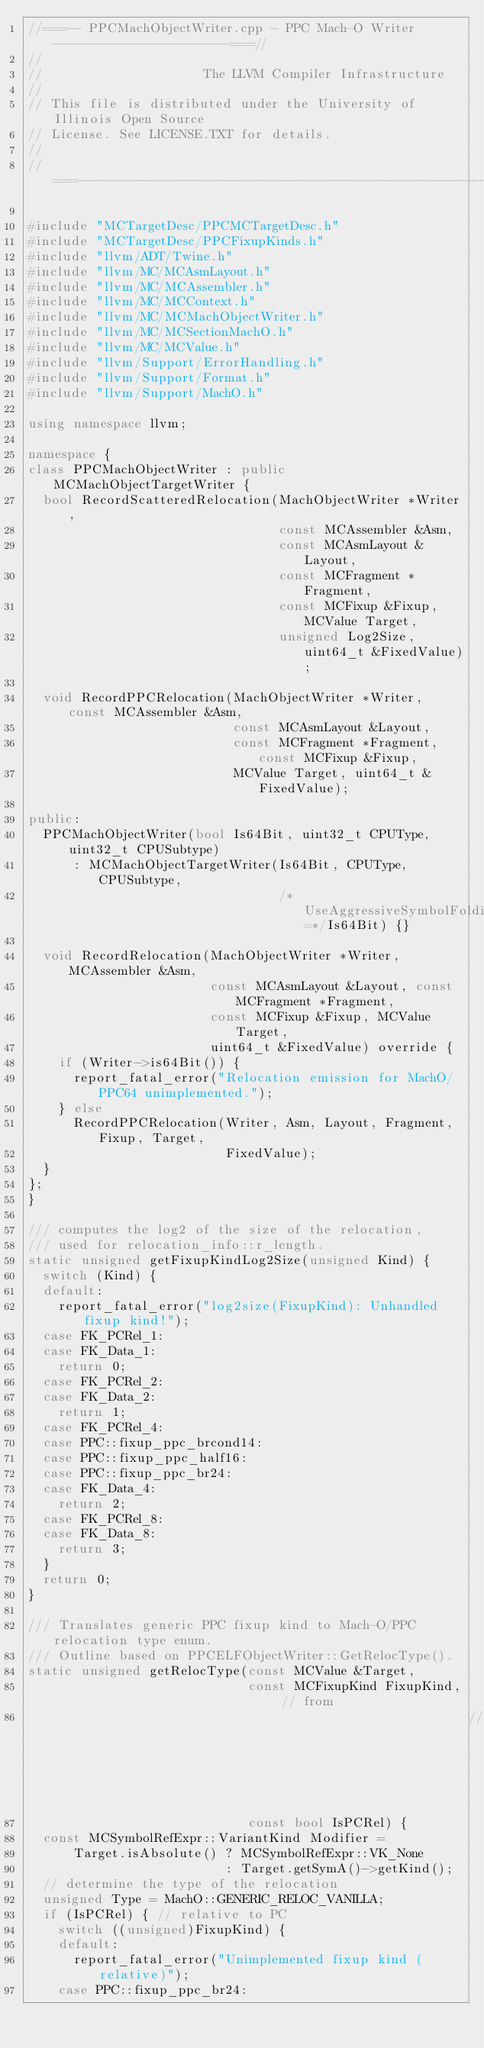Convert code to text. <code><loc_0><loc_0><loc_500><loc_500><_C++_>//===-- PPCMachObjectWriter.cpp - PPC Mach-O Writer -----------------------===//
//
//                     The LLVM Compiler Infrastructure
//
// This file is distributed under the University of Illinois Open Source
// License. See LICENSE.TXT for details.
//
//===----------------------------------------------------------------------===//

#include "MCTargetDesc/PPCMCTargetDesc.h"
#include "MCTargetDesc/PPCFixupKinds.h"
#include "llvm/ADT/Twine.h"
#include "llvm/MC/MCAsmLayout.h"
#include "llvm/MC/MCAssembler.h"
#include "llvm/MC/MCContext.h"
#include "llvm/MC/MCMachObjectWriter.h"
#include "llvm/MC/MCSectionMachO.h"
#include "llvm/MC/MCValue.h"
#include "llvm/Support/ErrorHandling.h"
#include "llvm/Support/Format.h"
#include "llvm/Support/MachO.h"

using namespace llvm;

namespace {
class PPCMachObjectWriter : public MCMachObjectTargetWriter {
  bool RecordScatteredRelocation(MachObjectWriter *Writer,
                                 const MCAssembler &Asm,
                                 const MCAsmLayout &Layout,
                                 const MCFragment *Fragment,
                                 const MCFixup &Fixup, MCValue Target,
                                 unsigned Log2Size, uint64_t &FixedValue);

  void RecordPPCRelocation(MachObjectWriter *Writer, const MCAssembler &Asm,
                           const MCAsmLayout &Layout,
                           const MCFragment *Fragment, const MCFixup &Fixup,
                           MCValue Target, uint64_t &FixedValue);

public:
  PPCMachObjectWriter(bool Is64Bit, uint32_t CPUType, uint32_t CPUSubtype)
      : MCMachObjectTargetWriter(Is64Bit, CPUType, CPUSubtype,
                                 /*UseAggressiveSymbolFolding=*/Is64Bit) {}

  void RecordRelocation(MachObjectWriter *Writer, MCAssembler &Asm,
                        const MCAsmLayout &Layout, const MCFragment *Fragment,
                        const MCFixup &Fixup, MCValue Target,
                        uint64_t &FixedValue) override {
    if (Writer->is64Bit()) {
      report_fatal_error("Relocation emission for MachO/PPC64 unimplemented.");
    } else
      RecordPPCRelocation(Writer, Asm, Layout, Fragment, Fixup, Target,
                          FixedValue);
  }
};
}

/// computes the log2 of the size of the relocation,
/// used for relocation_info::r_length.
static unsigned getFixupKindLog2Size(unsigned Kind) {
  switch (Kind) {
  default:
    report_fatal_error("log2size(FixupKind): Unhandled fixup kind!");
  case FK_PCRel_1:
  case FK_Data_1:
    return 0;
  case FK_PCRel_2:
  case FK_Data_2:
    return 1;
  case FK_PCRel_4:
  case PPC::fixup_ppc_brcond14:
  case PPC::fixup_ppc_half16:
  case PPC::fixup_ppc_br24:
  case FK_Data_4:
    return 2;
  case FK_PCRel_8:
  case FK_Data_8:
    return 3;
  }
  return 0;
}

/// Translates generic PPC fixup kind to Mach-O/PPC relocation type enum.
/// Outline based on PPCELFObjectWriter::GetRelocType().
static unsigned getRelocType(const MCValue &Target,
                             const MCFixupKind FixupKind, // from
                                                          // Fixup.getKind()
                             const bool IsPCRel) {
  const MCSymbolRefExpr::VariantKind Modifier =
      Target.isAbsolute() ? MCSymbolRefExpr::VK_None
                          : Target.getSymA()->getKind();
  // determine the type of the relocation
  unsigned Type = MachO::GENERIC_RELOC_VANILLA;
  if (IsPCRel) { // relative to PC
    switch ((unsigned)FixupKind) {
    default:
      report_fatal_error("Unimplemented fixup kind (relative)");
    case PPC::fixup_ppc_br24:</code> 